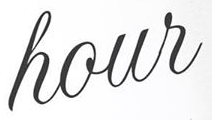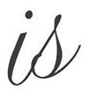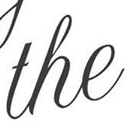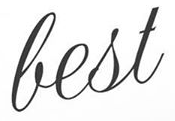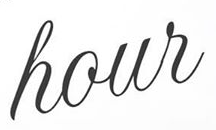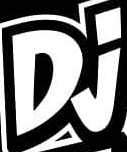What text appears in these images from left to right, separated by a semicolon? hour; is; the; best; hour; Dj 